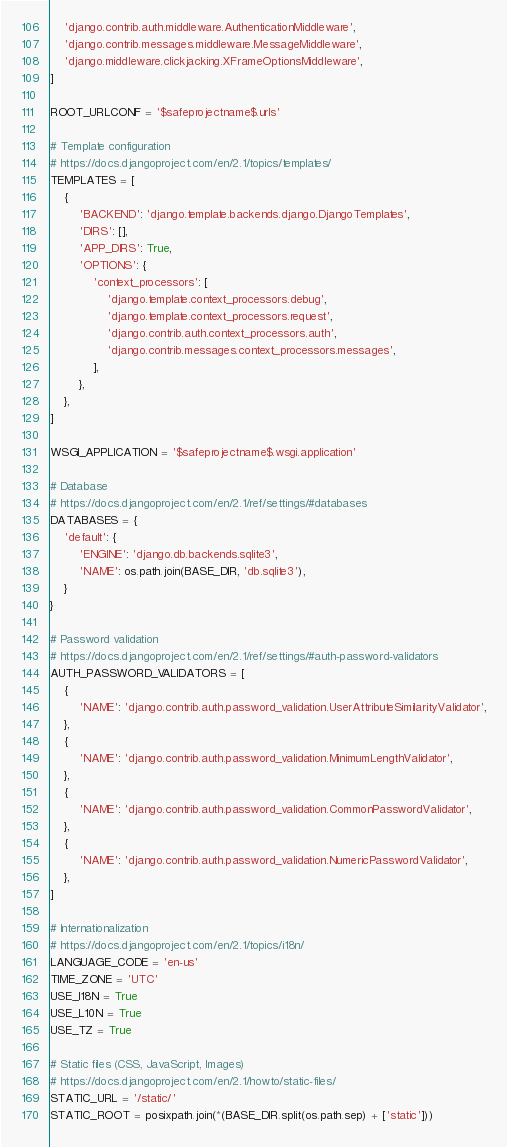<code> <loc_0><loc_0><loc_500><loc_500><_Python_>    'django.contrib.auth.middleware.AuthenticationMiddleware',
    'django.contrib.messages.middleware.MessageMiddleware',
    'django.middleware.clickjacking.XFrameOptionsMiddleware',
]

ROOT_URLCONF = '$safeprojectname$.urls'

# Template configuration
# https://docs.djangoproject.com/en/2.1/topics/templates/
TEMPLATES = [
    {
        'BACKEND': 'django.template.backends.django.DjangoTemplates',
        'DIRS': [],
        'APP_DIRS': True,
        'OPTIONS': {
            'context_processors': [
                'django.template.context_processors.debug',
                'django.template.context_processors.request',
                'django.contrib.auth.context_processors.auth',
                'django.contrib.messages.context_processors.messages',
            ],
        },
    },
]

WSGI_APPLICATION = '$safeprojectname$.wsgi.application'

# Database
# https://docs.djangoproject.com/en/2.1/ref/settings/#databases
DATABASES = {
    'default': {
        'ENGINE': 'django.db.backends.sqlite3',
        'NAME': os.path.join(BASE_DIR, 'db.sqlite3'),
    }
}

# Password validation
# https://docs.djangoproject.com/en/2.1/ref/settings/#auth-password-validators
AUTH_PASSWORD_VALIDATORS = [
    {
        'NAME': 'django.contrib.auth.password_validation.UserAttributeSimilarityValidator',
    },
    {
        'NAME': 'django.contrib.auth.password_validation.MinimumLengthValidator',
    },
    {
        'NAME': 'django.contrib.auth.password_validation.CommonPasswordValidator',
    },
    {
        'NAME': 'django.contrib.auth.password_validation.NumericPasswordValidator',
    },
]

# Internationalization
# https://docs.djangoproject.com/en/2.1/topics/i18n/
LANGUAGE_CODE = 'en-us'
TIME_ZONE = 'UTC'
USE_I18N = True
USE_L10N = True
USE_TZ = True

# Static files (CSS, JavaScript, Images)
# https://docs.djangoproject.com/en/2.1/howto/static-files/
STATIC_URL = '/static/'
STATIC_ROOT = posixpath.join(*(BASE_DIR.split(os.path.sep) + ['static']))
</code> 